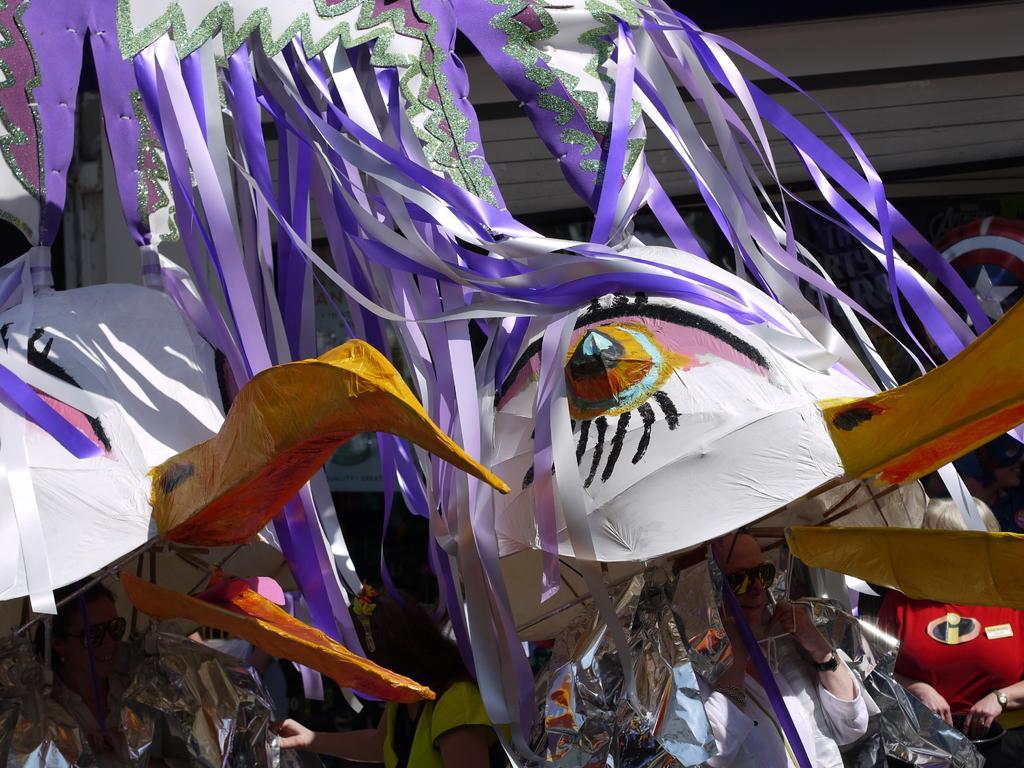Describe this image in one or two sentences. This picture seems to be clicked outside. In the foreground we can see the group of persons and we can see the depictions of some objects and the ribbons. In the background we can see some other objects. 